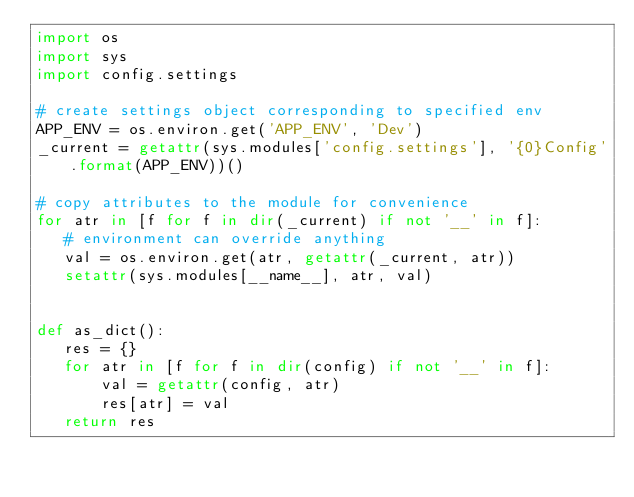Convert code to text. <code><loc_0><loc_0><loc_500><loc_500><_Python_>import os
import sys
import config.settings

# create settings object corresponding to specified env
APP_ENV = os.environ.get('APP_ENV', 'Dev')
_current = getattr(sys.modules['config.settings'], '{0}Config'.format(APP_ENV))()

# copy attributes to the module for convenience
for atr in [f for f in dir(_current) if not '__' in f]:
   # environment can override anything
   val = os.environ.get(atr, getattr(_current, atr))
   setattr(sys.modules[__name__], atr, val)


def as_dict():
   res = {}
   for atr in [f for f in dir(config) if not '__' in f]:
       val = getattr(config, atr)
       res[atr] = val
   return res
</code> 